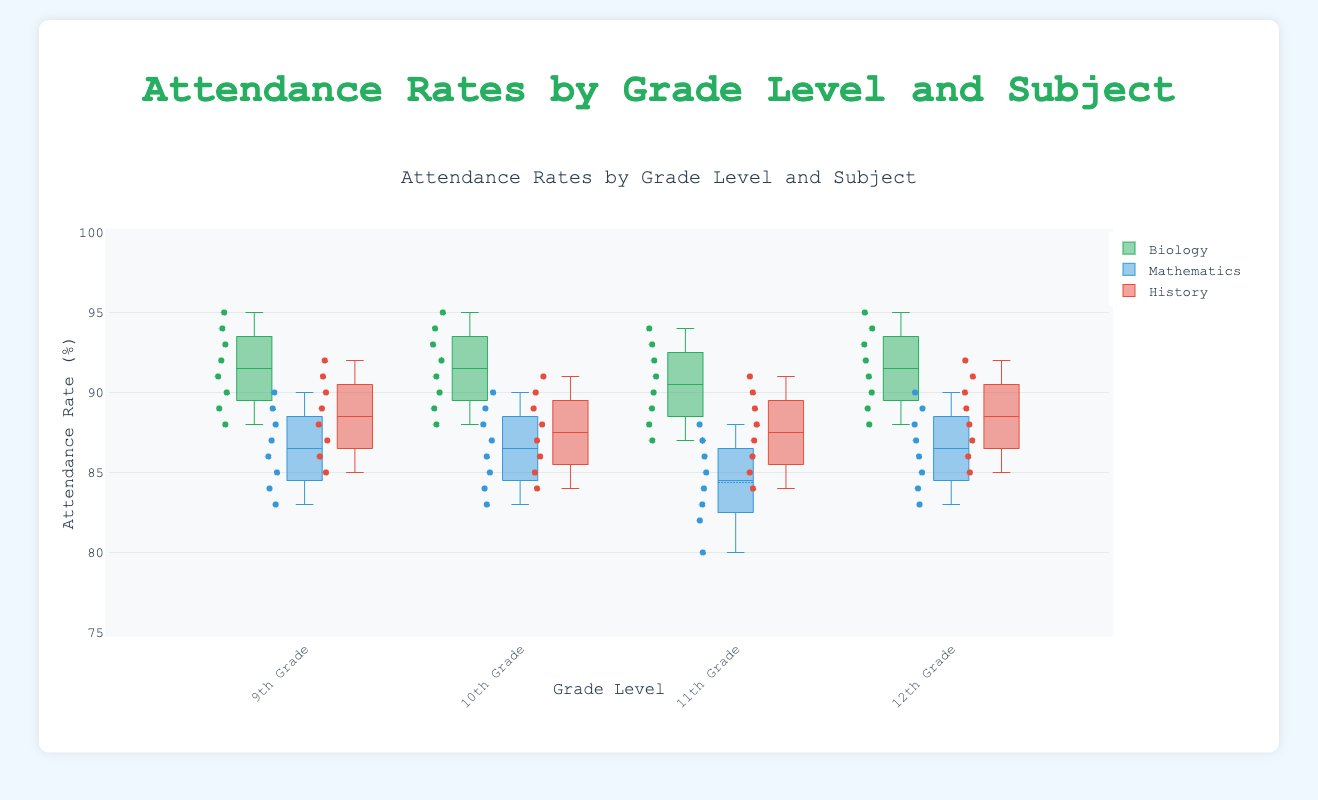What is the title of the plot? The title of the plot is displayed at the top.
Answer: Attendance Rates by Grade Level and Subject What is the range of the y-axis? The y-axis range is shown on the left side of the plot.
Answer: 75 to 100 Which subject has the highest median attendance rate in 9th Grade? The median is the middle line in each box, and by comparing the Biology, Mathematics, and History boxes, you can identify the highest.
Answer: Biology Between 9th Grade and 12th Grade, which grade level has a higher median attendance rate in Mathematics? Compare the median lines (middle lines) of the 9th Grade and 12th Grade boxes for Mathematics.
Answer: 12th Grade Which grade and subject combination has the lowest minimum attendance rate? Look at the bottom whisker of each box to find the lowest point.
Answer: 11th Grade Mathematics Calculate the average of the median attendance rates for Biology across all grade levels. Find the median for Biology in 9th, 10th, 11th, and 12th Grades, then sum them up and divide by 4. (92+92+91+91)/4 = 91.5
Answer: 91.5 Which subject shows the least variation in attendance rates in 10th Grade? The variation in a box plot is indicated by the length of the box and whiskers; the shortest box and whiskers mean least variation.
Answer: History Compare the upper quartiles of 9th Grade Biology and 11th Grade Biology. Which one is higher? The upper quartile is the top edge of the box.
Answer: 9th Grade Biology Which subject has the most consistent attendance rates across all grades? Consistency is indicated by the smallest height of boxes and whiskers across all grade levels.
Answer: History Are there any outliers in the attendance rates for 11th Grade Mathematics? Outliers are usually shown as individual points outside the whiskers.
Answer: No 